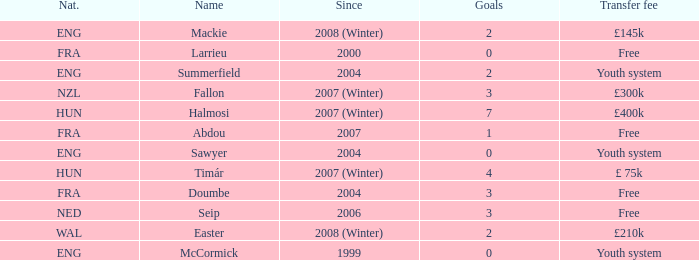What is the average goals Sawyer has? 0.0. 